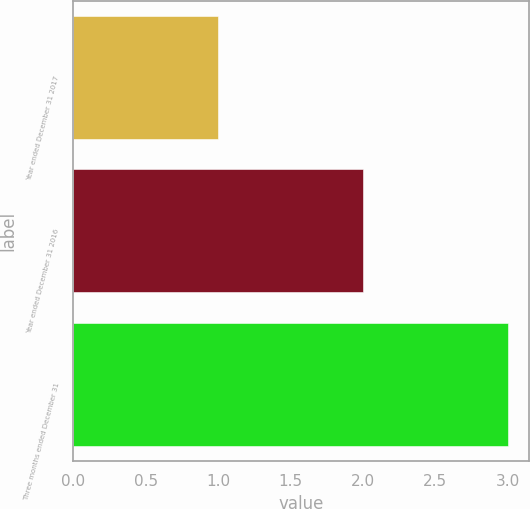Convert chart to OTSL. <chart><loc_0><loc_0><loc_500><loc_500><bar_chart><fcel>Year ended December 31 2017<fcel>Year ended December 31 2016<fcel>Three months ended December 31<nl><fcel>1<fcel>2<fcel>3<nl></chart> 